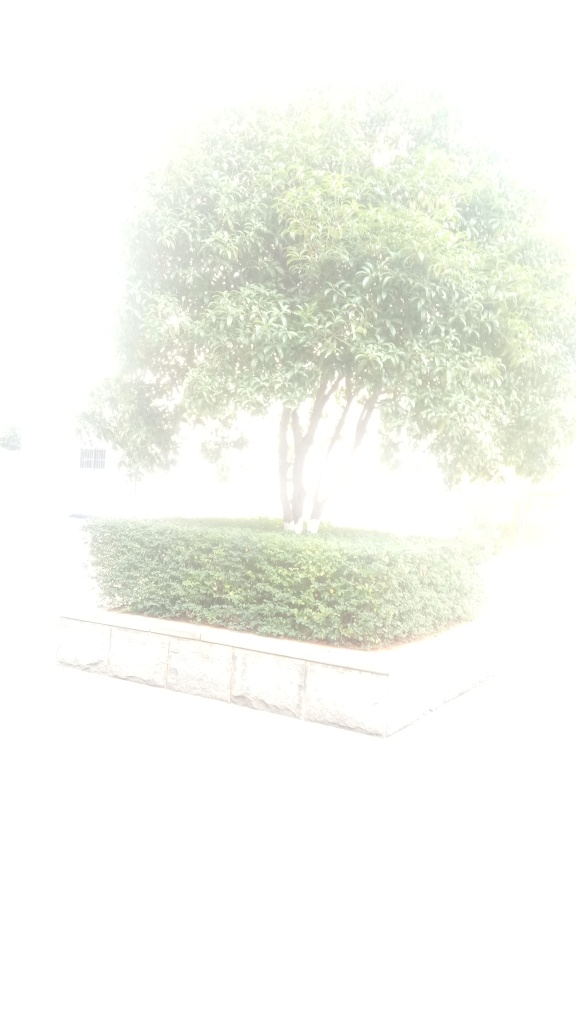Is there anything that can be done to correct an image that's this overexposed? If an overexposed image has some areas with recoverable details, you can try to correct it using photo editing software. Adjustments like lowering the exposure, increasing the contrast, and tweaking the highlights and shadows may help. However, if an image is severely overexposed across the entire frame, as in this case, it might not be recoverable and re-taking the photograph with proper exposure settings would be the best option. 